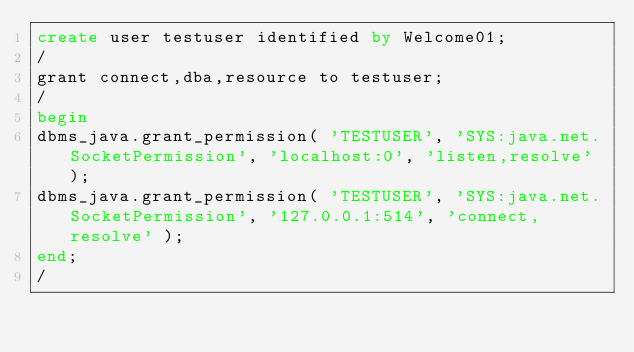Convert code to text. <code><loc_0><loc_0><loc_500><loc_500><_SQL_>create user testuser identified by Welcome01;
/
grant connect,dba,resource to testuser;
/
begin
dbms_java.grant_permission( 'TESTUSER', 'SYS:java.net.SocketPermission', 'localhost:0', 'listen,resolve' );
dbms_java.grant_permission( 'TESTUSER', 'SYS:java.net.SocketPermission', '127.0.0.1:514', 'connect,resolve' );
end;
/
</code> 